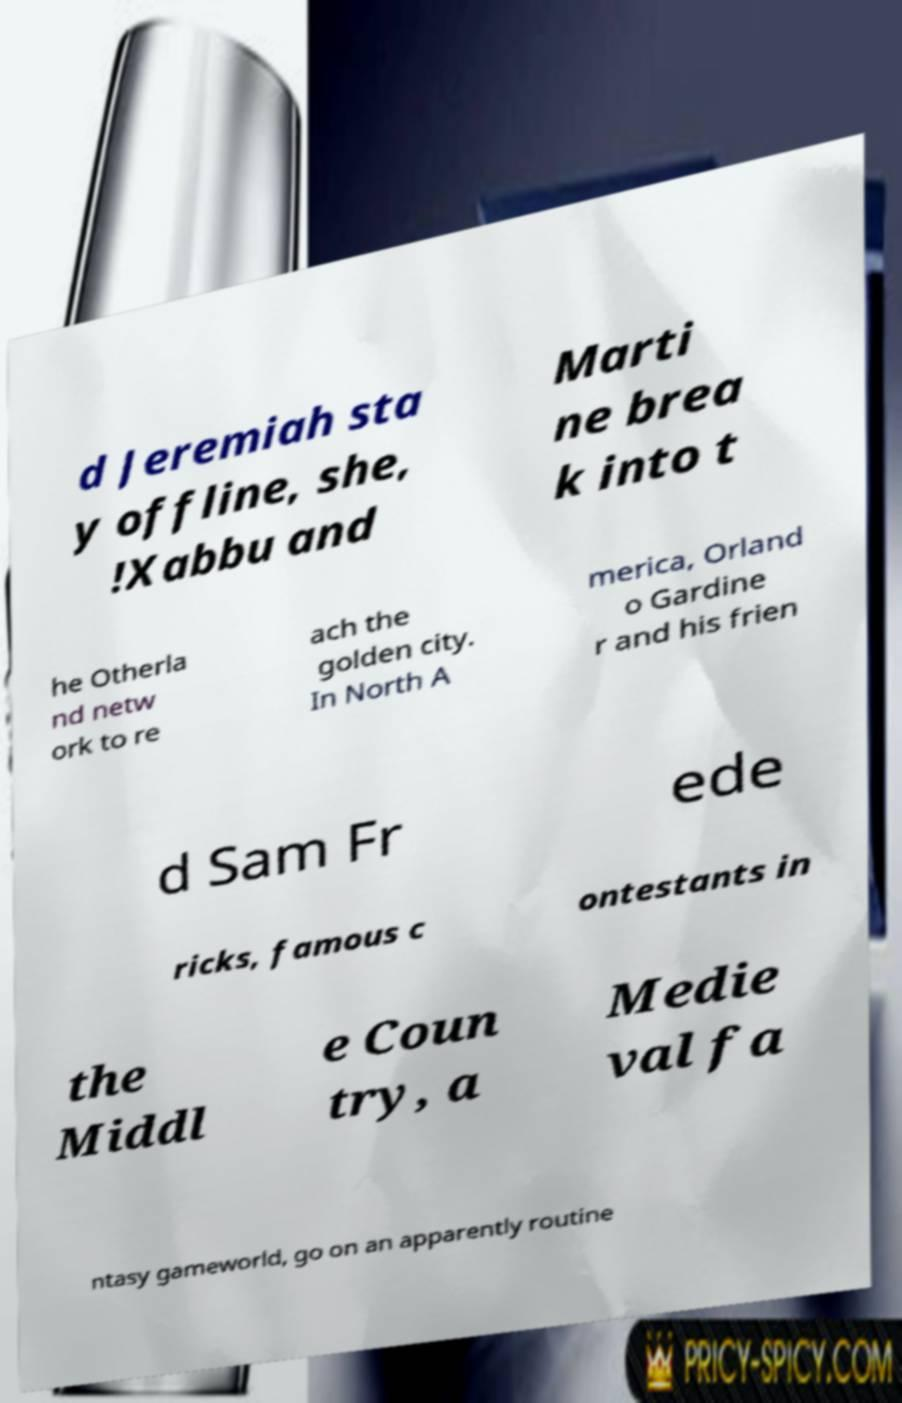Can you accurately transcribe the text from the provided image for me? d Jeremiah sta y offline, she, !Xabbu and Marti ne brea k into t he Otherla nd netw ork to re ach the golden city. In North A merica, Orland o Gardine r and his frien d Sam Fr ede ricks, famous c ontestants in the Middl e Coun try, a Medie val fa ntasy gameworld, go on an apparently routine 